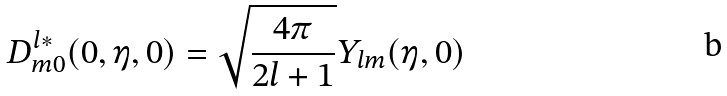Convert formula to latex. <formula><loc_0><loc_0><loc_500><loc_500>D _ { m 0 } ^ { l \ast } ( 0 , \eta , 0 ) = \sqrt { \frac { 4 \pi } { 2 l + 1 } } Y _ { l m } ( \eta , 0 )</formula> 